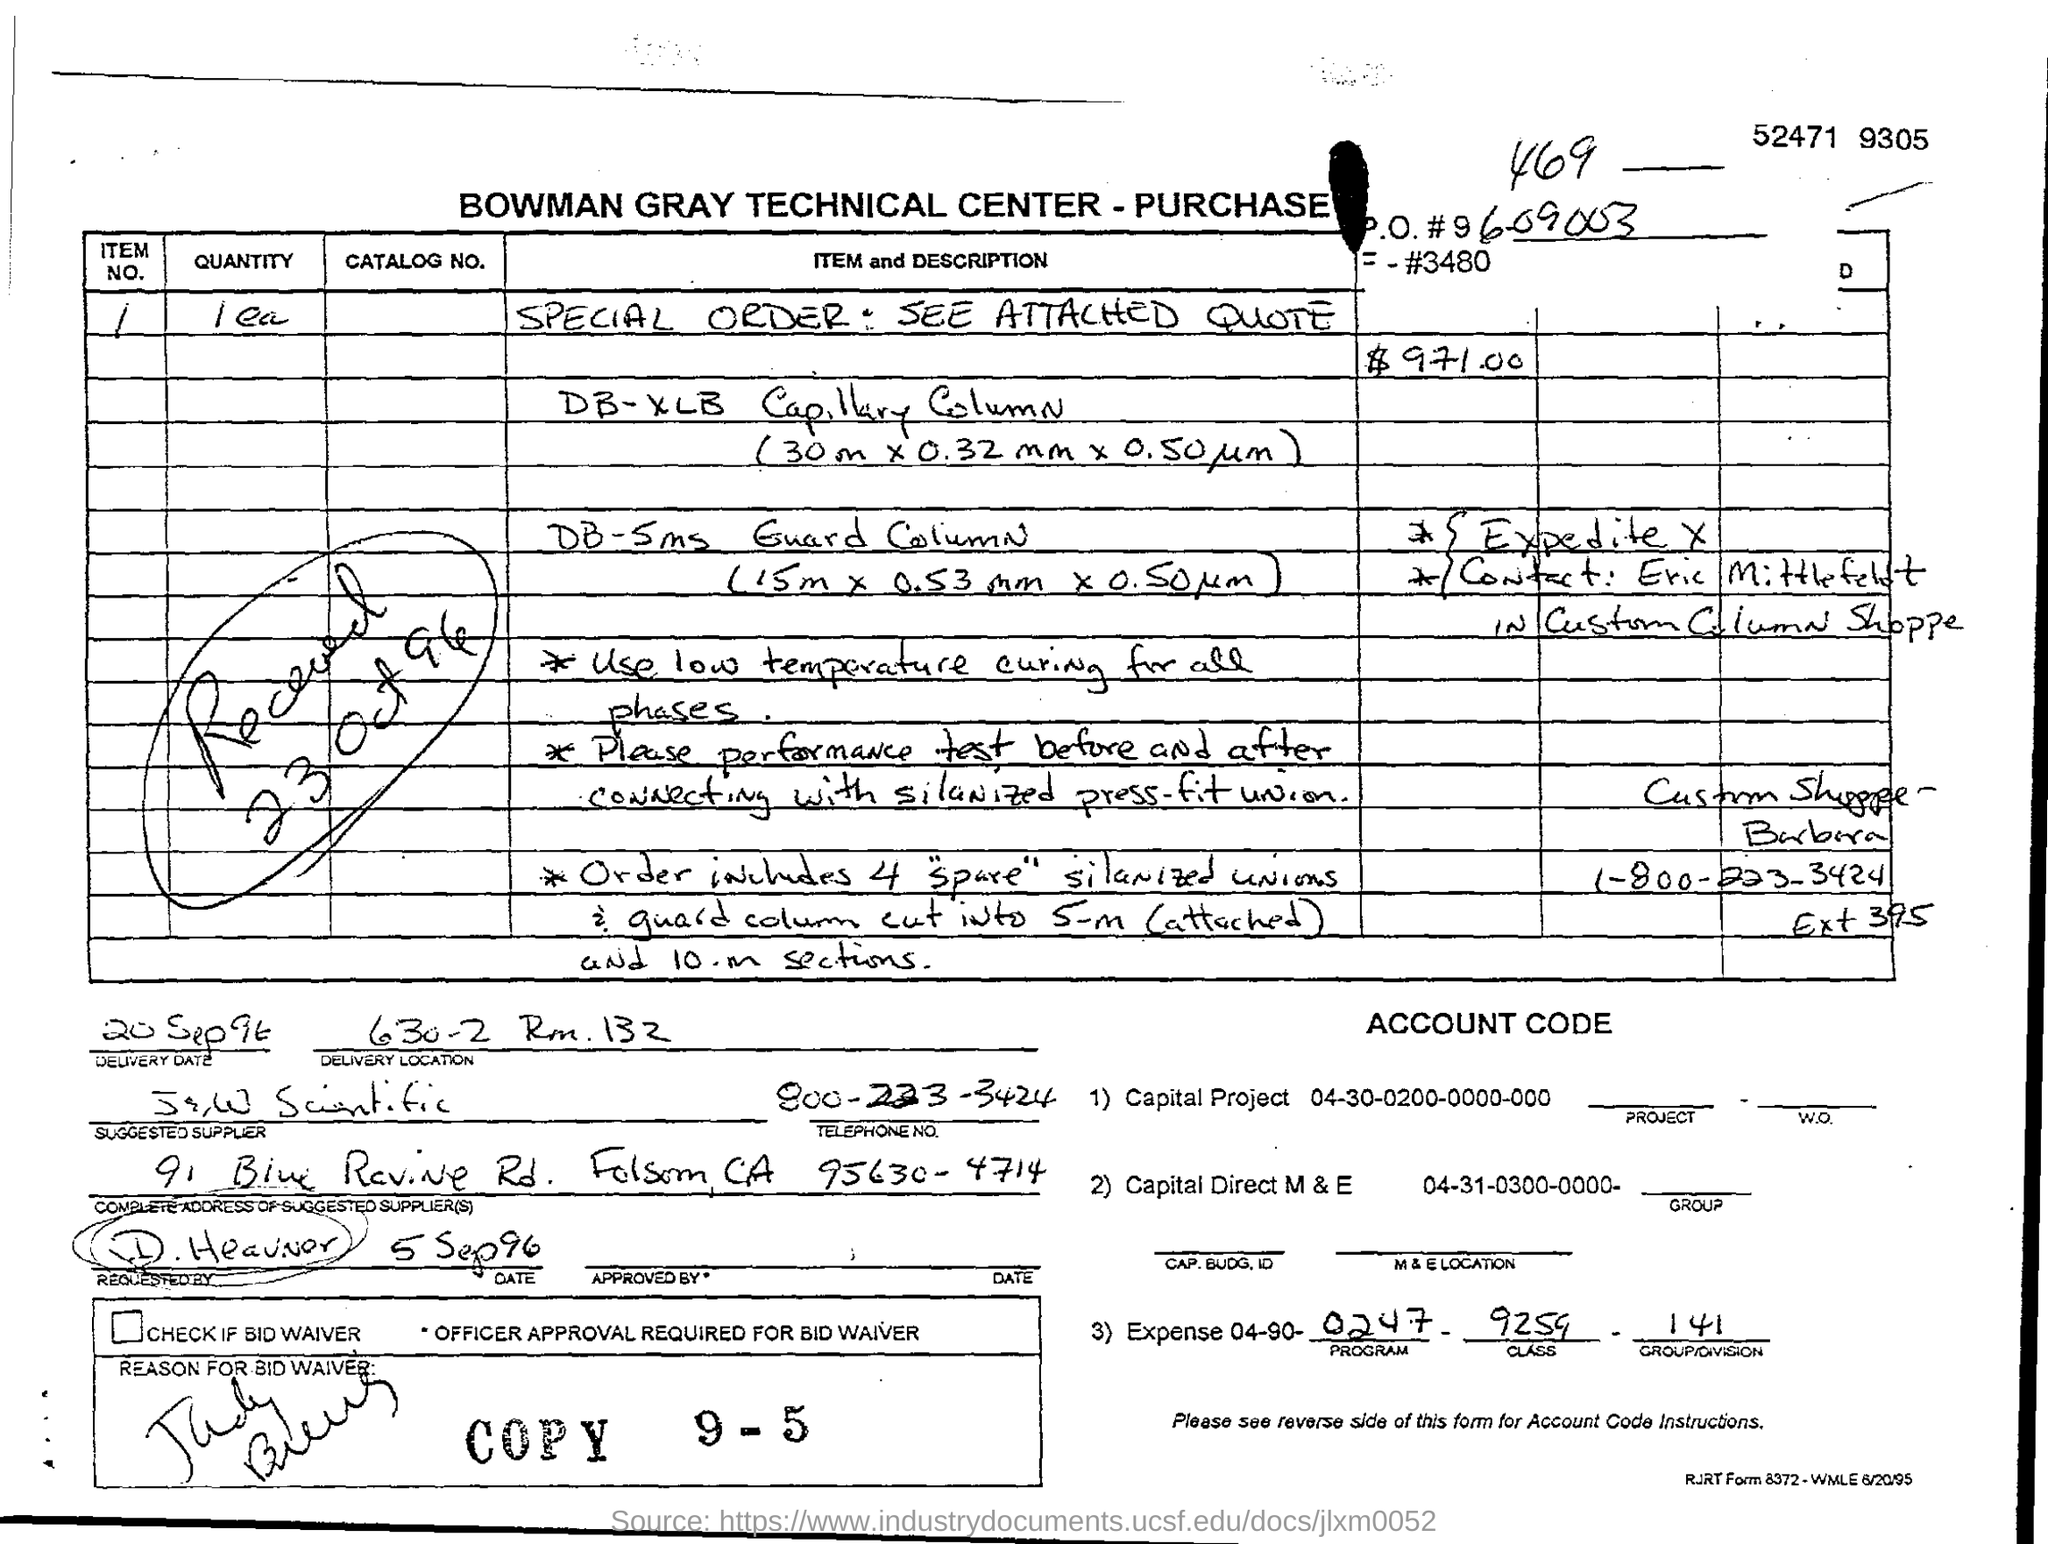IT IS THE PURCHASE ORDER OF WHICH CENTER?
Offer a terse response. BOWMAN GRAY TECHNICAL CENTER. WHAT SHOULD BE DONE BEFORE AND AFTER CONNECTING WITH SILANIZED PRESS FIT UNION?
Keep it short and to the point. PERFORMANCE TEST. THE ORDER CONTAINS HOW MANY "SPARE" SILANIZED UNIONS?
Ensure brevity in your answer.  4. WHEN WAS THE ORDER RECIEVED?
Provide a short and direct response. 23 Oct 96. WHAT IS THE DELIVERY DATE?
Keep it short and to the point. 20 SEP 96. 